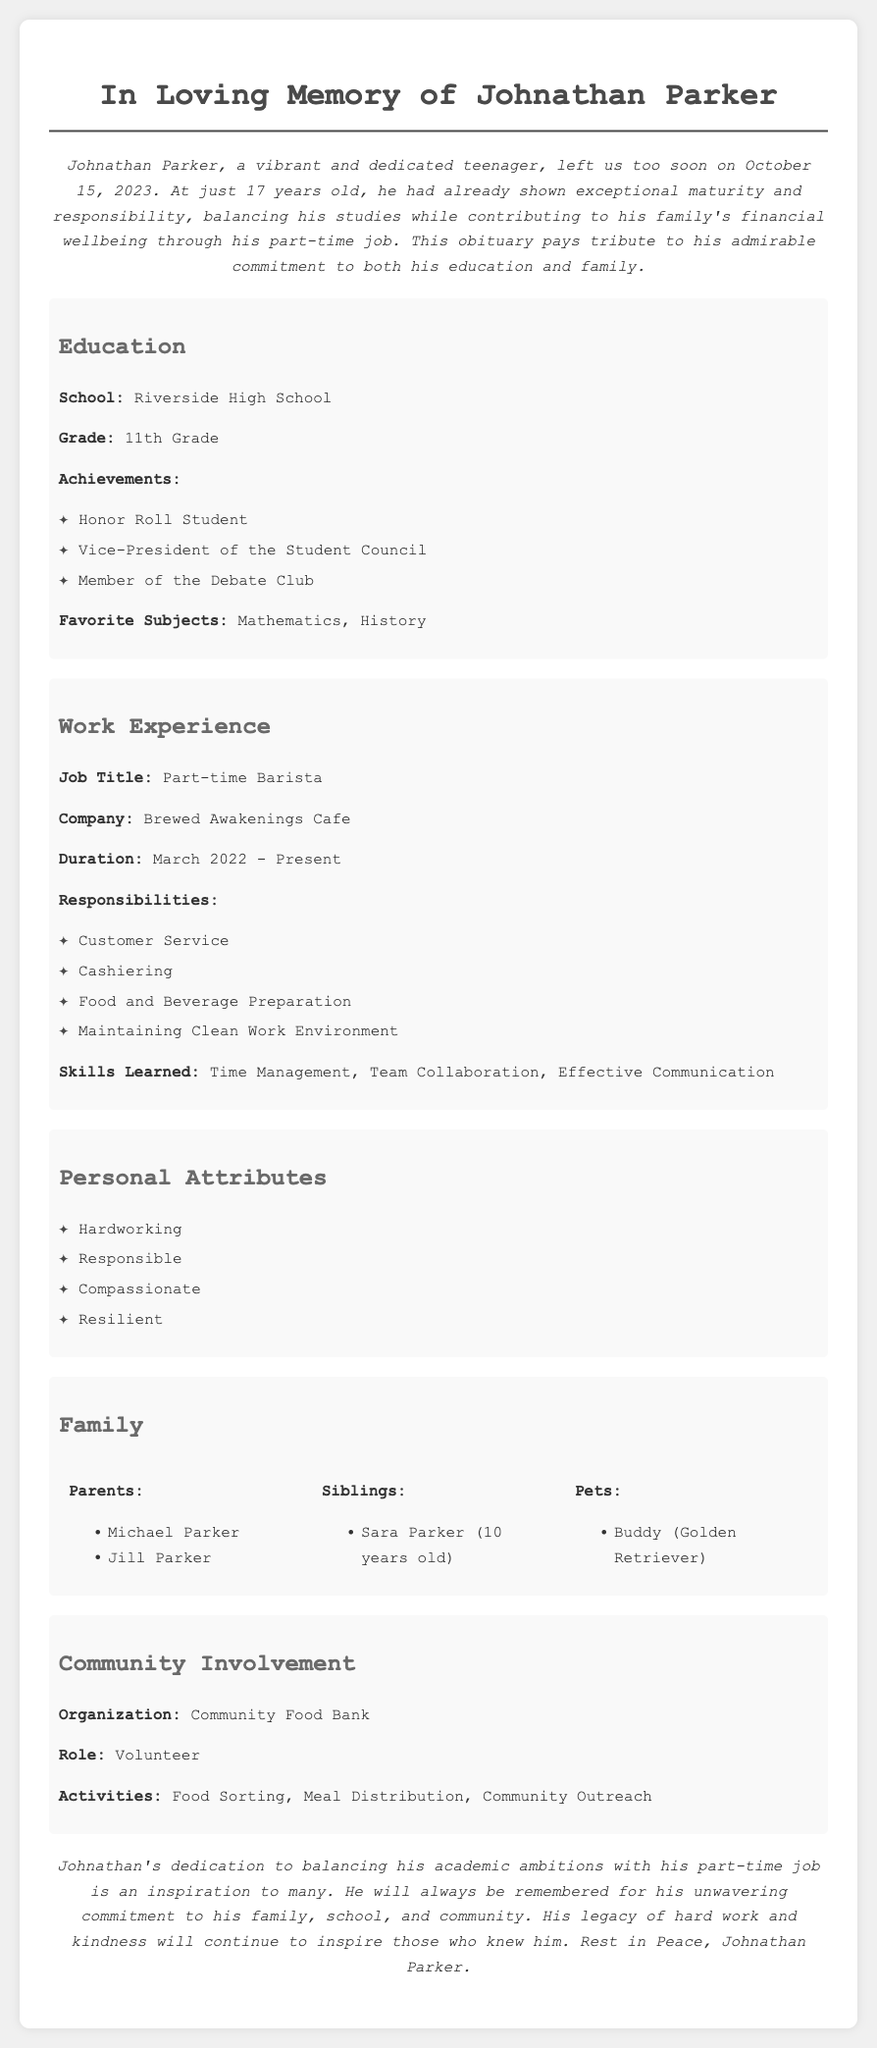What was Johnathan Parker's age at the time of passing? The obituary states that Johnathan Parker was only 17 years old when he passed away.
Answer: 17 years old What school did Johnathan attend? The document mentions that he attended Riverside High School.
Answer: Riverside High School What was Johnathan's job title? According to the document, Johnathan was a part-time barista.
Answer: Part-time Barista What achievements did Johnathan have in school? The achievements listed for Johnathan include being an Honor Roll Student, Vice-President of the Student Council, and a member of the Debate Club.
Answer: Honor Roll Student, Vice-President of the Student Council, Member of the Debate Club What family member is mentioned as being 10 years old? The document lists Sara Parker as Johnathan's sibling, who is 10 years old.
Answer: Sara Parker What organization did Johnathan volunteer for? The obituary specifies that he volunteered for the Community Food Bank.
Answer: Community Food Bank What responsibilities did Johnathan have at his job? The responsibilities listed include Customer Service, Cashiering, Food and Beverage Preparation, and Maintaining Clean Work Environment.
Answer: Customer Service, Cashiering, Food and Beverage Preparation, Maintaining Clean Work Environment How long did Johnathan work at Brewed Awakenings Cafe? The document states that he worked there from March 2022 until his passing in October 2023, making it a duration of approximately 1 year and 7 months.
Answer: March 2022 - Present What personal attributes are mentioned in the obituary? The document highlights qualities such as Hardworking, Responsible, Compassionate, and Resilient.
Answer: Hardworking, Responsible, Compassionate, Resilient 